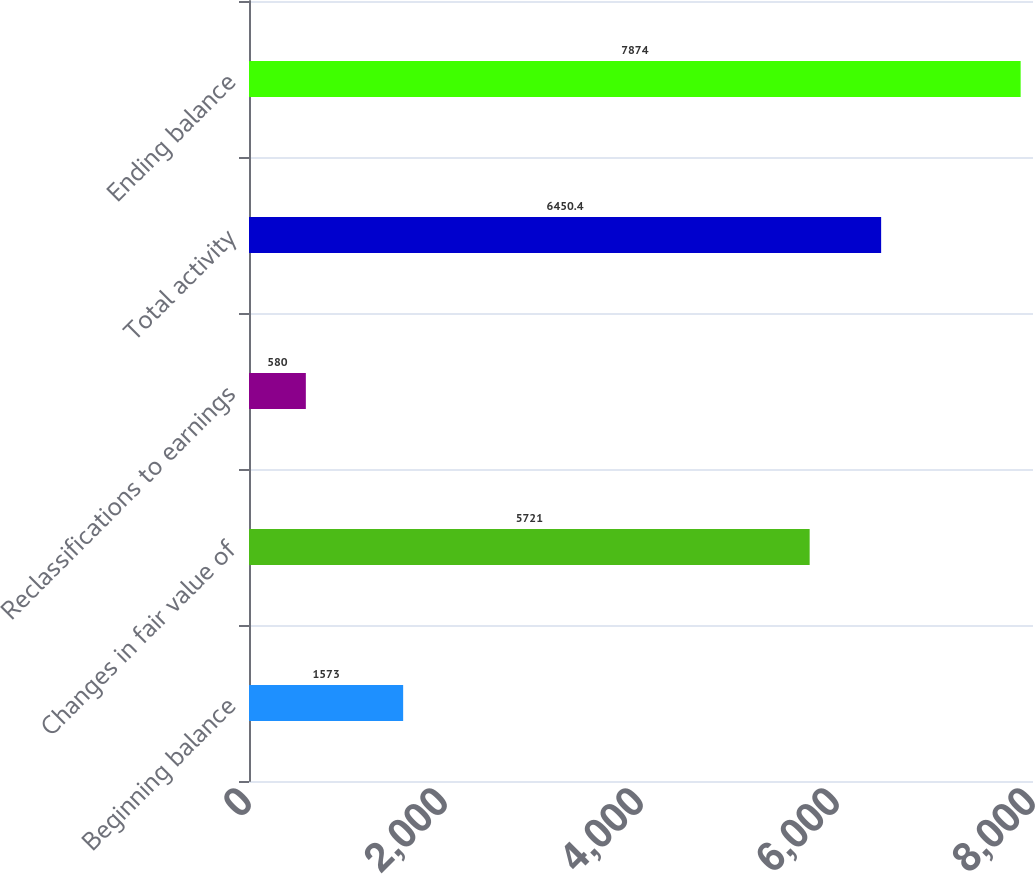Convert chart to OTSL. <chart><loc_0><loc_0><loc_500><loc_500><bar_chart><fcel>Beginning balance<fcel>Changes in fair value of<fcel>Reclassifications to earnings<fcel>Total activity<fcel>Ending balance<nl><fcel>1573<fcel>5721<fcel>580<fcel>6450.4<fcel>7874<nl></chart> 